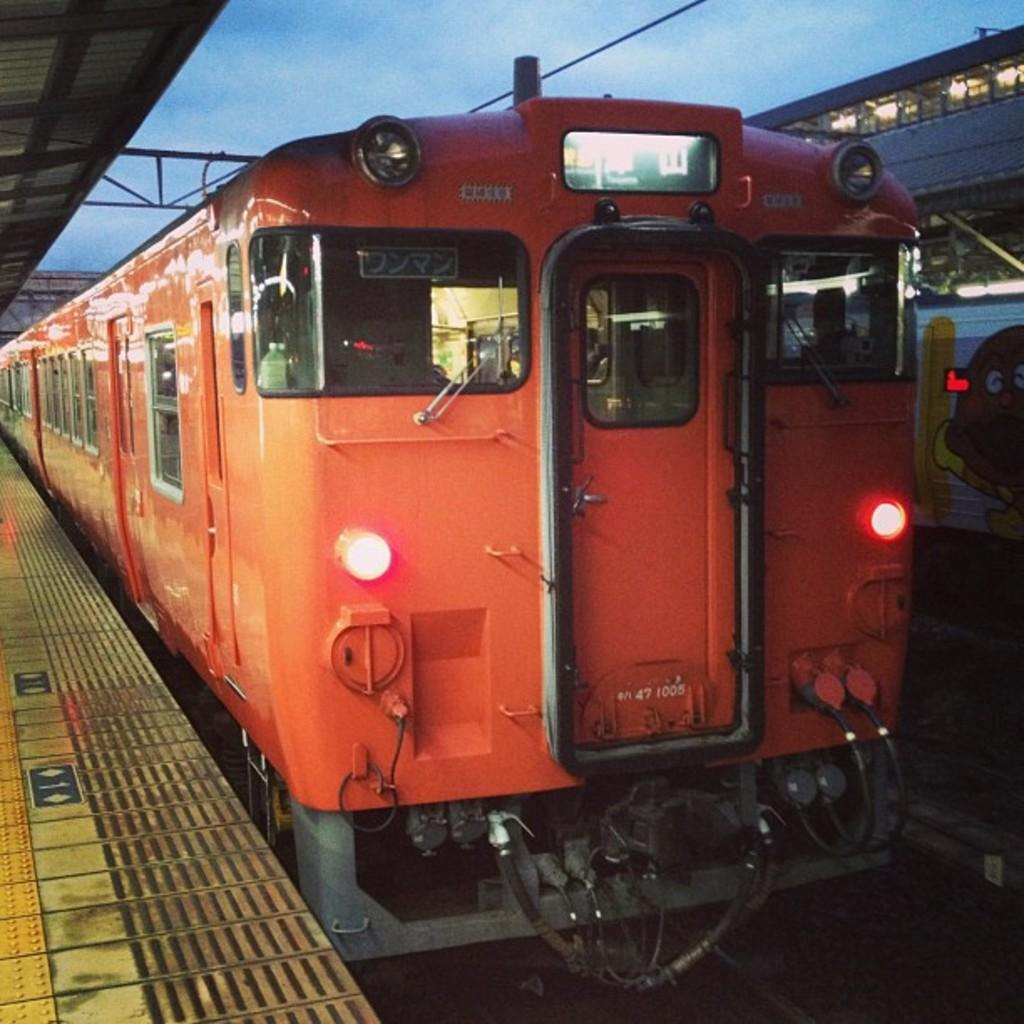What type of vehicles are on the track in the image? There are trains on the track in the image. What can be seen on the trains in the image? There are lights associated with the trains. What structure is visible to the left of the image? There is a platform visible to the left of the image. What is visible in the background of the image? The sky is visible in the background of the image. What type of soda is being served on the platform in the image? There is no soda present in the image; it features trains on a track with lights, a platform, and a visible sky in the background. 